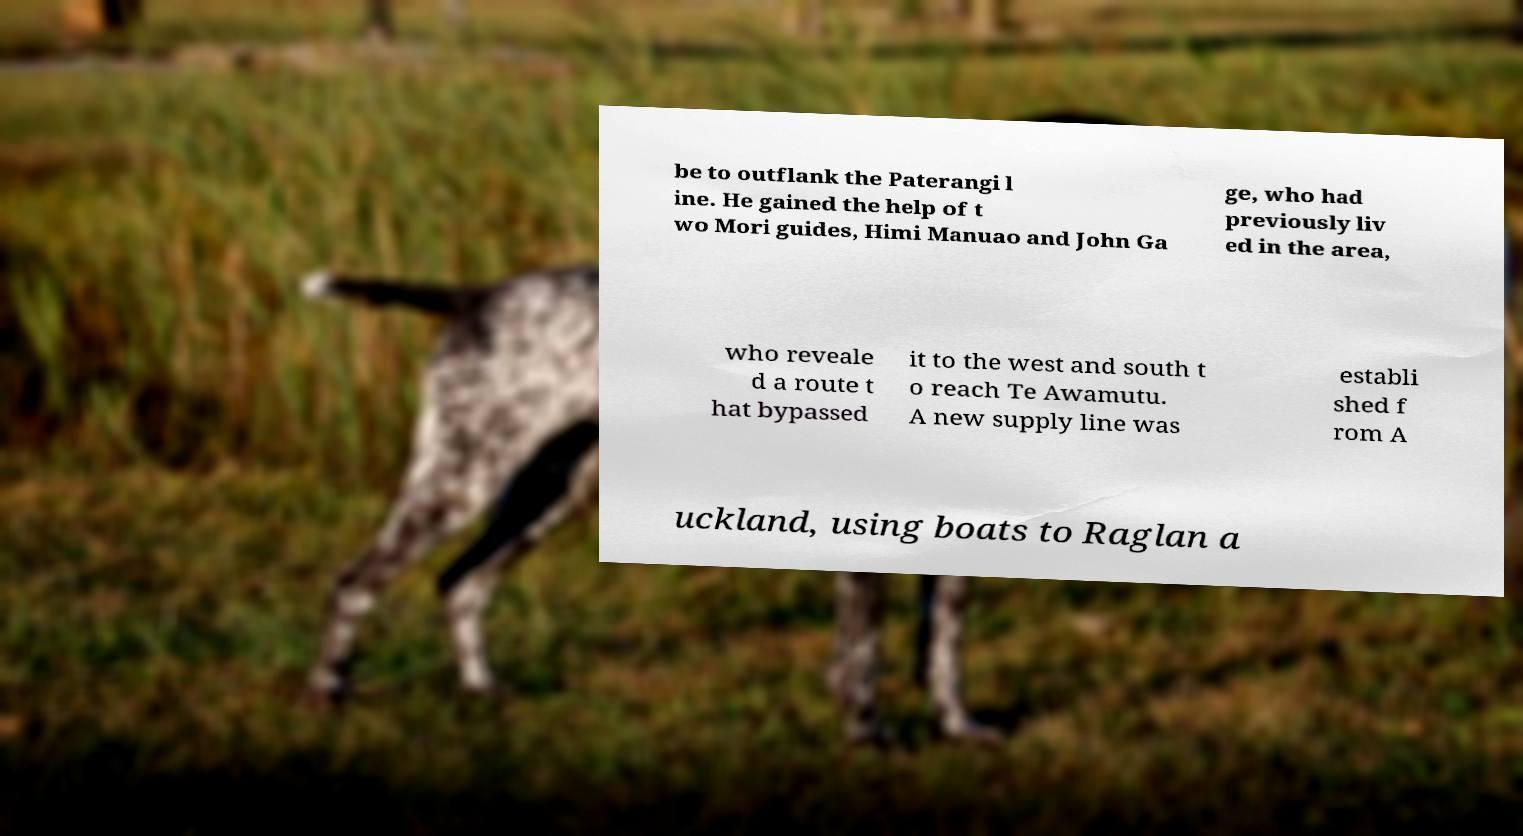I need the written content from this picture converted into text. Can you do that? be to outflank the Paterangi l ine. He gained the help of t wo Mori guides, Himi Manuao and John Ga ge, who had previously liv ed in the area, who reveale d a route t hat bypassed it to the west and south t o reach Te Awamutu. A new supply line was establi shed f rom A uckland, using boats to Raglan a 